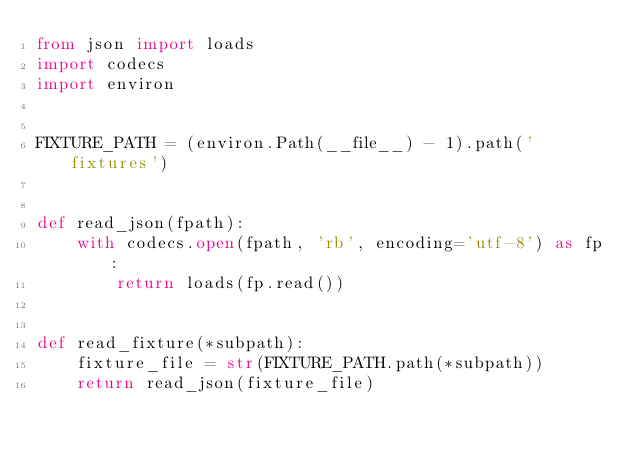<code> <loc_0><loc_0><loc_500><loc_500><_Python_>from json import loads
import codecs
import environ


FIXTURE_PATH = (environ.Path(__file__) - 1).path('fixtures')


def read_json(fpath):
    with codecs.open(fpath, 'rb', encoding='utf-8') as fp:
        return loads(fp.read())


def read_fixture(*subpath):
    fixture_file = str(FIXTURE_PATH.path(*subpath))
    return read_json(fixture_file)
</code> 